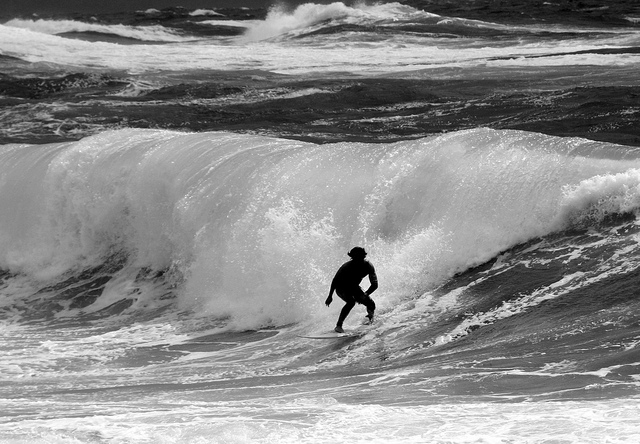How high are the waves?
Answer the question using a single word or phrase. 6 ft Can you tell is this is a man or woman? No Is the person wearing a hat? Yes 